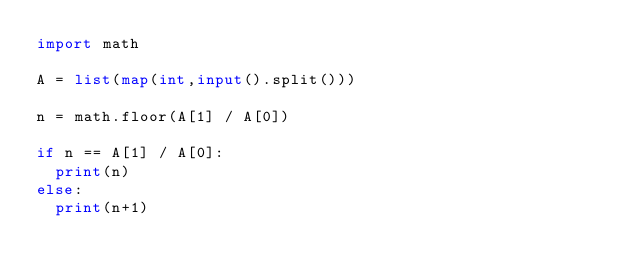<code> <loc_0><loc_0><loc_500><loc_500><_Python_>import math

A = list(map(int,input().split()))

n = math.floor(A[1] / A[0])

if n == A[1] / A[0]:
  print(n)
else:
  print(n+1)</code> 